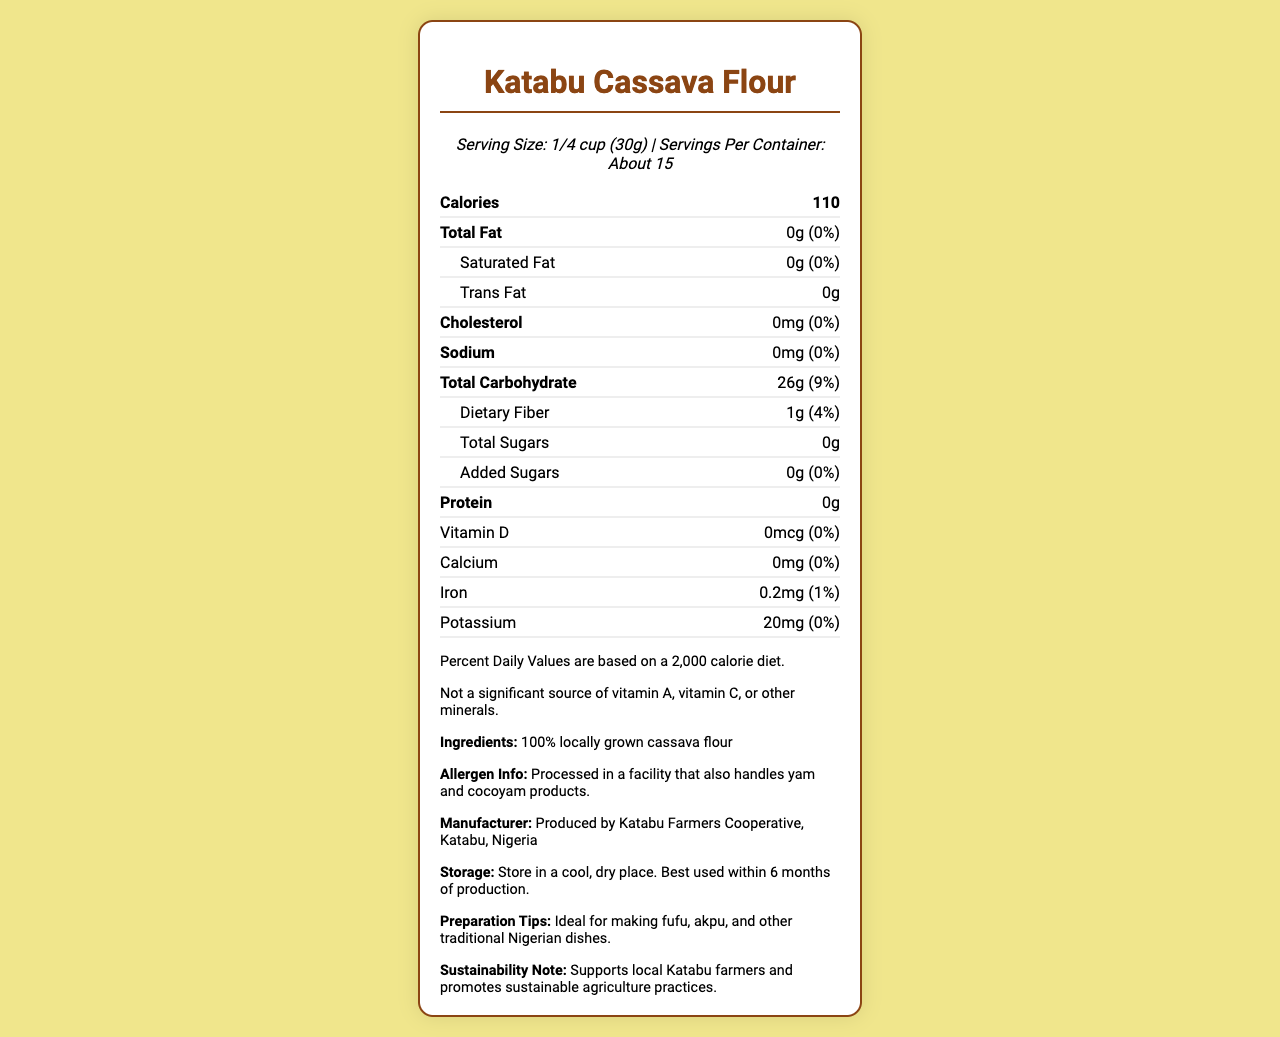what is the serving size of Katabu Cassava Flour? The serving size is mentioned explicitly under the serving info section.
Answer: 1/4 cup (30g) how much total carbohydrates are there per serving? The total carbohydrate content per serving is stated in the document as 26g.
Answer: 26g how much dietary fiber is present in one serving? The dietary fiber content is listed as 1g in the nutrition facts table.
Answer: 1g how many calories are in one serving of this cassava flour? The document specifies that one serving of the flour contains 110 calories.
Answer: 110 what is the percentage of daily value for sodium in this product? The daily value percentage for sodium is given as 0%.
Answer: 0% what ingredients does this product contain? The ingredients section clearly states that it contains 100% locally grown cassava flour.
Answer: 100% locally grown cassava flour who is the manufacturer of Katabu Cassava Flour? The manufacturer info section specifies that Katabu Farmers Cooperative produces this flour.
Answer: Katabu Farmers Cooperative, Katabu, Nigeria what is the total fat content in this product per serving? The nutrition facts table indicates that the total fat content is 0g per serving.
Answer: 0g how many servings are there per container? The document mentions that there are about 15 servings per container.
Answer: About 15 what is the potassium content in one serving? The nutrition facts table lists the potassium content as 20mg per serving.
Answer: 20mg Is there any added sugar in Katabu Cassava Flour? The document specifies that there are 0g of added sugars.
Answer: No is this flour a good source of protein? The document shows that the protein content is 0g per serving, indicating that it is not a good source of protein.
Answer: No are vitamin A and vitamin C significant in this product? The additional info section mentions that it is not a significant source of vitamin A or vitamin C.
Answer: No which of the following nutrients is present in the highest amount per serving? A. Vitamin D B. Iron C. Protein D. Sugars The iron content is 0.2mg, higher compared to vitamin D, protein, and sugars, which are all 0g or 0mcg.
Answer: B. Iron what is the best way to store this product? A. In a refrigerator B. In a cool, dry place C. In a warm, humid place D. Exposed to air The storage instructions section specifies to store the product in a cool, dry place.
Answer: B. In a cool, dry place how should you use this cassava flour? A. For making cakes B. For frying C. For making fufu and akpu D. As a salad dressing The preparation tips mention using the flour for making fufu, akpu, and other traditional Nigerian dishes.
Answer: C. For making fufu and akpu does this product support local farmers? The sustainability note states that the product supports local Katabu farmers and promotes sustainable agriculture practices.
Answer: Yes is this cassava flour a significant source of calcium? The document shows that the calcium content is 0mg per serving, indicating it is not a significant source.
Answer: No is the facility where this product is processed also handling yam and cocoyam products? The allergen info section mentions that it is processed in a facility that also handles yam and cocoyam products.
Answer: Yes where can I find information about the production date of this flour? The document does not provide any details about the production date.
Answer: Not enough information summarize the key nutritional facts of Katabu Cassava Flour. The summary highlights the main nutritional components such as calories, carbs, fats, and proteins, describes its ingredients, and notes the sustainability aspect mentioned in the document.
Answer: Katabu Cassava Flour provides 110 calories per serving. It is high in carbohydrates (26g) and has low fat (0g) and protein (0g). The product contains minimal vitamins and minerals, with 20mg of potassium and 0.2mg of iron per serving. It is made from 100% locally grown cassava and supports sustainable farming practices. 